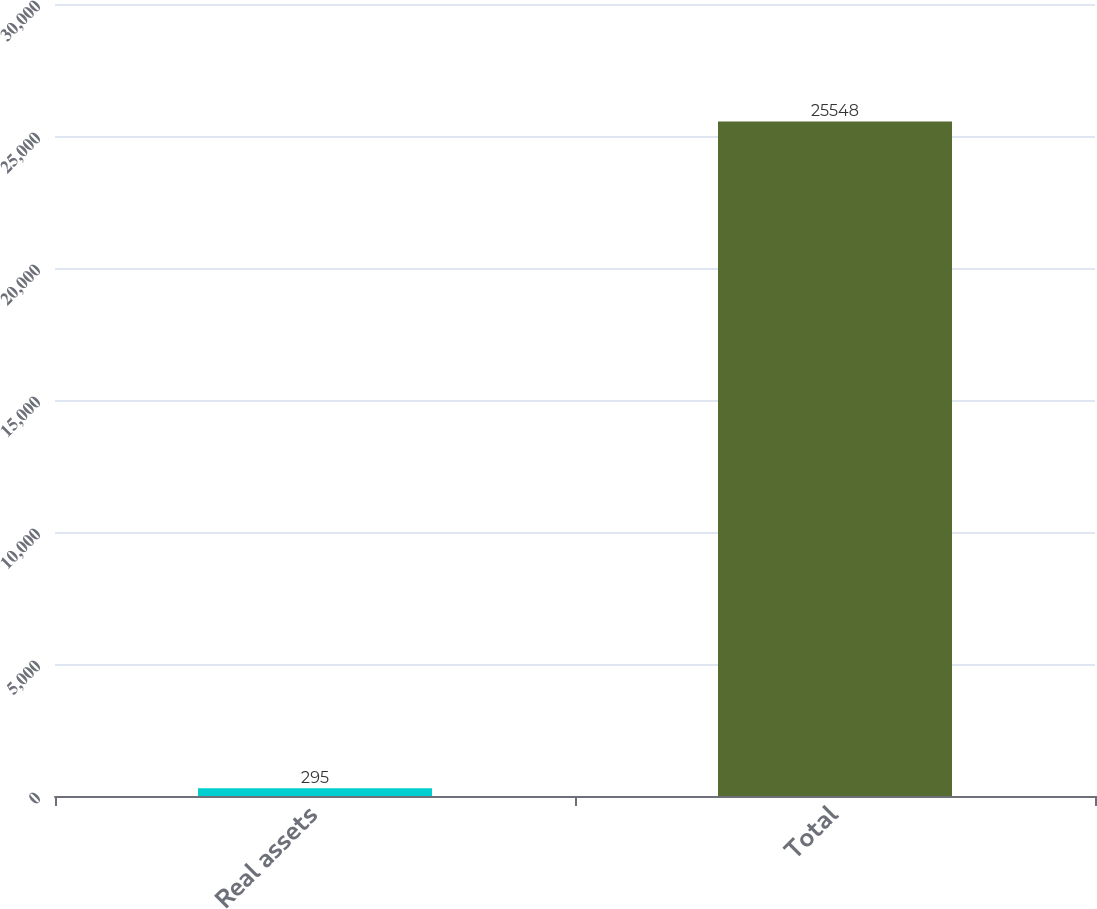<chart> <loc_0><loc_0><loc_500><loc_500><bar_chart><fcel>Real assets<fcel>Total<nl><fcel>295<fcel>25548<nl></chart> 